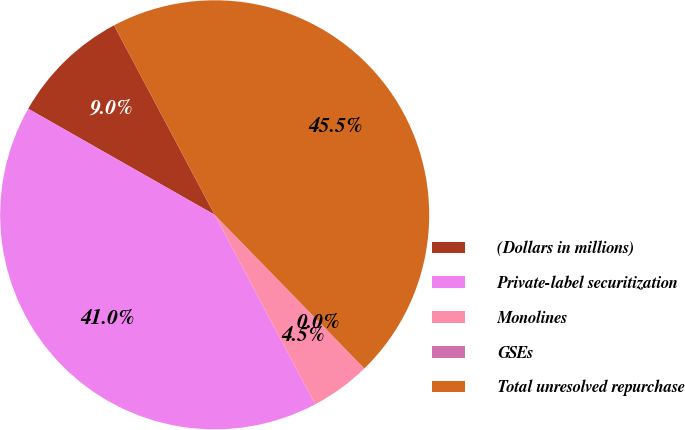<chart> <loc_0><loc_0><loc_500><loc_500><pie_chart><fcel>(Dollars in millions)<fcel>Private-label securitization<fcel>Monolines<fcel>GSEs<fcel>Total unresolved repurchase<nl><fcel>9.0%<fcel>40.99%<fcel>4.51%<fcel>0.02%<fcel>45.48%<nl></chart> 